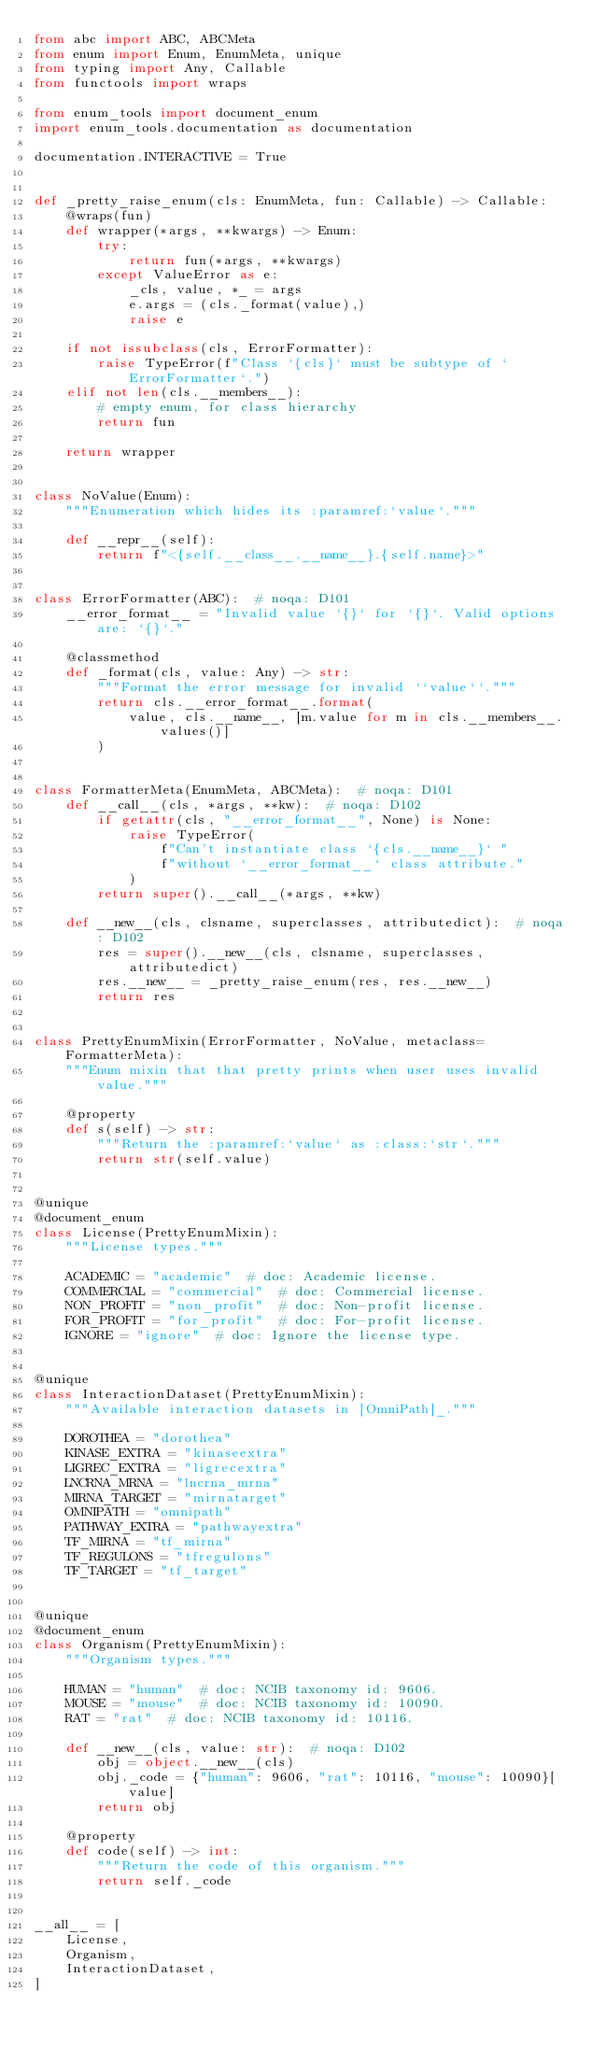Convert code to text. <code><loc_0><loc_0><loc_500><loc_500><_Python_>from abc import ABC, ABCMeta
from enum import Enum, EnumMeta, unique
from typing import Any, Callable
from functools import wraps

from enum_tools import document_enum
import enum_tools.documentation as documentation

documentation.INTERACTIVE = True


def _pretty_raise_enum(cls: EnumMeta, fun: Callable) -> Callable:
    @wraps(fun)
    def wrapper(*args, **kwargs) -> Enum:
        try:
            return fun(*args, **kwargs)
        except ValueError as e:
            _cls, value, *_ = args
            e.args = (cls._format(value),)
            raise e

    if not issubclass(cls, ErrorFormatter):
        raise TypeError(f"Class `{cls}` must be subtype of `ErrorFormatter`.")
    elif not len(cls.__members__):
        # empty enum, for class hierarchy
        return fun

    return wrapper


class NoValue(Enum):
    """Enumeration which hides its :paramref:`value`."""

    def __repr__(self):
        return f"<{self.__class__.__name__}.{self.name}>"


class ErrorFormatter(ABC):  # noqa: D101
    __error_format__ = "Invalid value `{}` for `{}`. Valid options are: `{}`."

    @classmethod
    def _format(cls, value: Any) -> str:
        """Format the error message for invalid ``value``."""
        return cls.__error_format__.format(
            value, cls.__name__, [m.value for m in cls.__members__.values()]
        )


class FormatterMeta(EnumMeta, ABCMeta):  # noqa: D101
    def __call__(cls, *args, **kw):  # noqa: D102
        if getattr(cls, "__error_format__", None) is None:
            raise TypeError(
                f"Can't instantiate class `{cls.__name__}` "
                f"without `__error_format__` class attribute."
            )
        return super().__call__(*args, **kw)

    def __new__(cls, clsname, superclasses, attributedict):  # noqa: D102
        res = super().__new__(cls, clsname, superclasses, attributedict)
        res.__new__ = _pretty_raise_enum(res, res.__new__)
        return res


class PrettyEnumMixin(ErrorFormatter, NoValue, metaclass=FormatterMeta):
    """Enum mixin that that pretty prints when user uses invalid value."""

    @property
    def s(self) -> str:
        """Return the :paramref:`value` as :class:`str`."""
        return str(self.value)


@unique
@document_enum
class License(PrettyEnumMixin):
    """License types."""

    ACADEMIC = "academic"  # doc: Academic license.
    COMMERCIAL = "commercial"  # doc: Commercial license.
    NON_PROFIT = "non_profit"  # doc: Non-profit license.
    FOR_PROFIT = "for_profit"  # doc: For-profit license.
    IGNORE = "ignore"  # doc: Ignore the license type.


@unique
class InteractionDataset(PrettyEnumMixin):
    """Available interaction datasets in [OmniPath]_."""

    DOROTHEA = "dorothea"
    KINASE_EXTRA = "kinaseextra"
    LIGREC_EXTRA = "ligrecextra"
    LNCRNA_MRNA = "lncrna_mrna"
    MIRNA_TARGET = "mirnatarget"
    OMNIPATH = "omnipath"
    PATHWAY_EXTRA = "pathwayextra"
    TF_MIRNA = "tf_mirna"
    TF_REGULONS = "tfregulons"
    TF_TARGET = "tf_target"


@unique
@document_enum
class Organism(PrettyEnumMixin):
    """Organism types."""

    HUMAN = "human"  # doc: NCIB taxonomy id: 9606.
    MOUSE = "mouse"  # doc: NCIB taxonomy id: 10090.
    RAT = "rat"  # doc: NCIB taxonomy id: 10116.

    def __new__(cls, value: str):  # noqa: D102
        obj = object.__new__(cls)
        obj._code = {"human": 9606, "rat": 10116, "mouse": 10090}[value]
        return obj

    @property
    def code(self) -> int:
        """Return the code of this organism."""
        return self._code


__all__ = [
    License,
    Organism,
    InteractionDataset,
]
</code> 